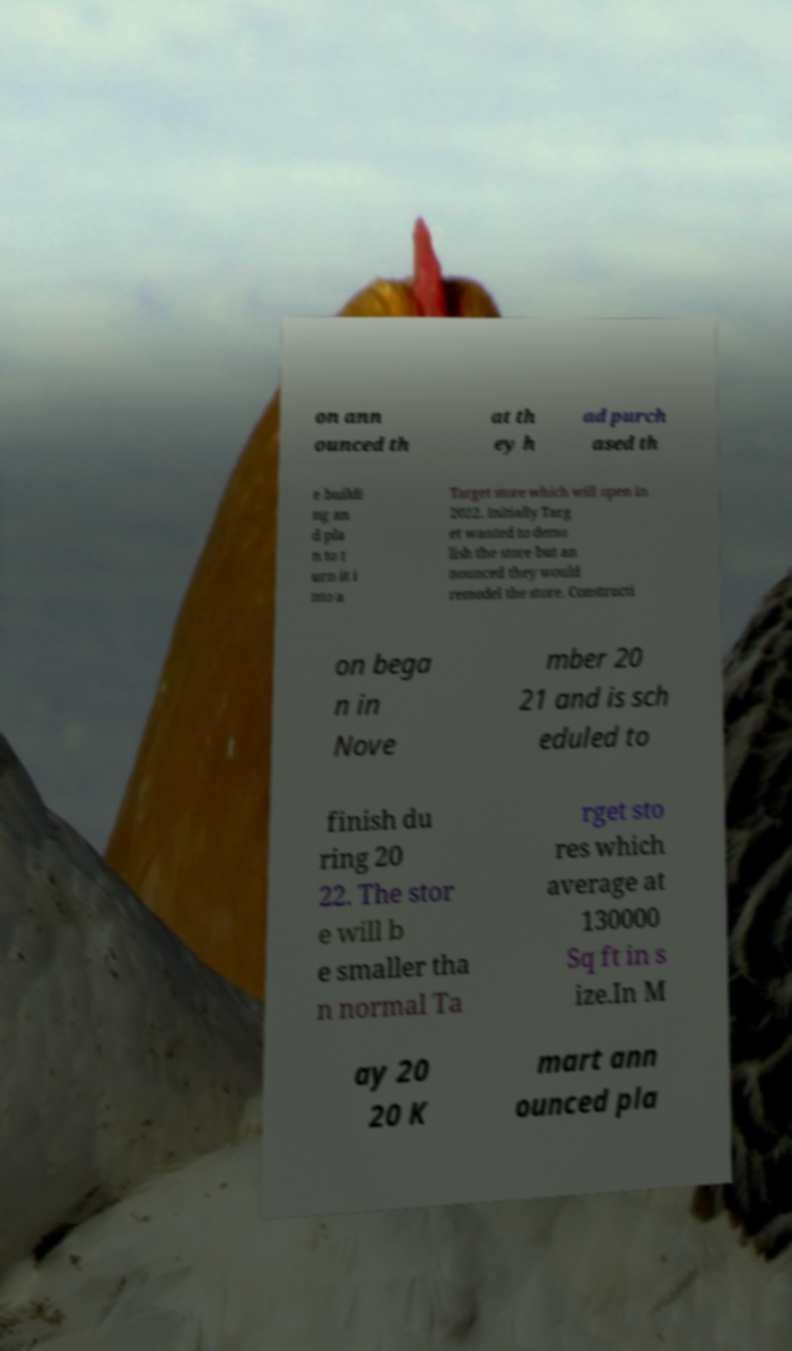I need the written content from this picture converted into text. Can you do that? on ann ounced th at th ey h ad purch ased th e buildi ng an d pla n to t urn it i nto a Target store which will open in 2022. Initially Targ et wanted to demo lish the store but an nounced they would remodel the store. Constructi on bega n in Nove mber 20 21 and is sch eduled to finish du ring 20 22. The stor e will b e smaller tha n normal Ta rget sto res which average at 130000 Sq ft in s ize.In M ay 20 20 K mart ann ounced pla 